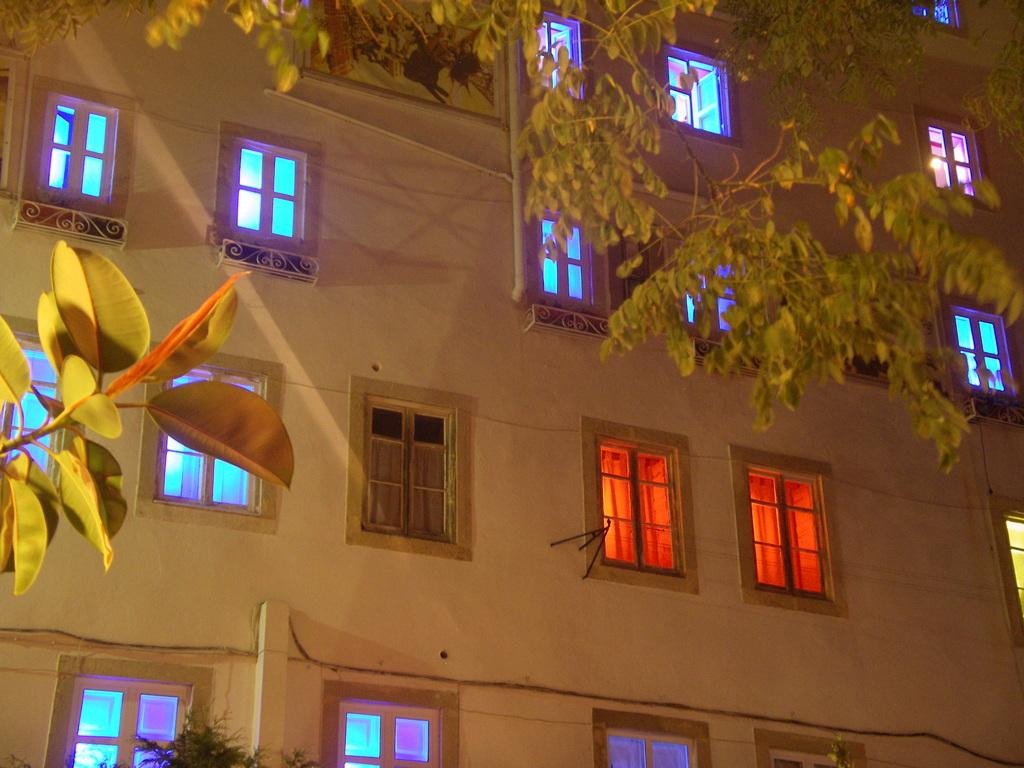What type of vegetation can be seen in the image? There are trees in the image. What type of structure is present in the image? There is a building in the image. What feature can be observed on the building? The building has windows. Where are the cherries placed in the image? There are no cherries present in the image. What type of toys can be seen being played with in the image? There are no toys or play activities depicted in the image. 